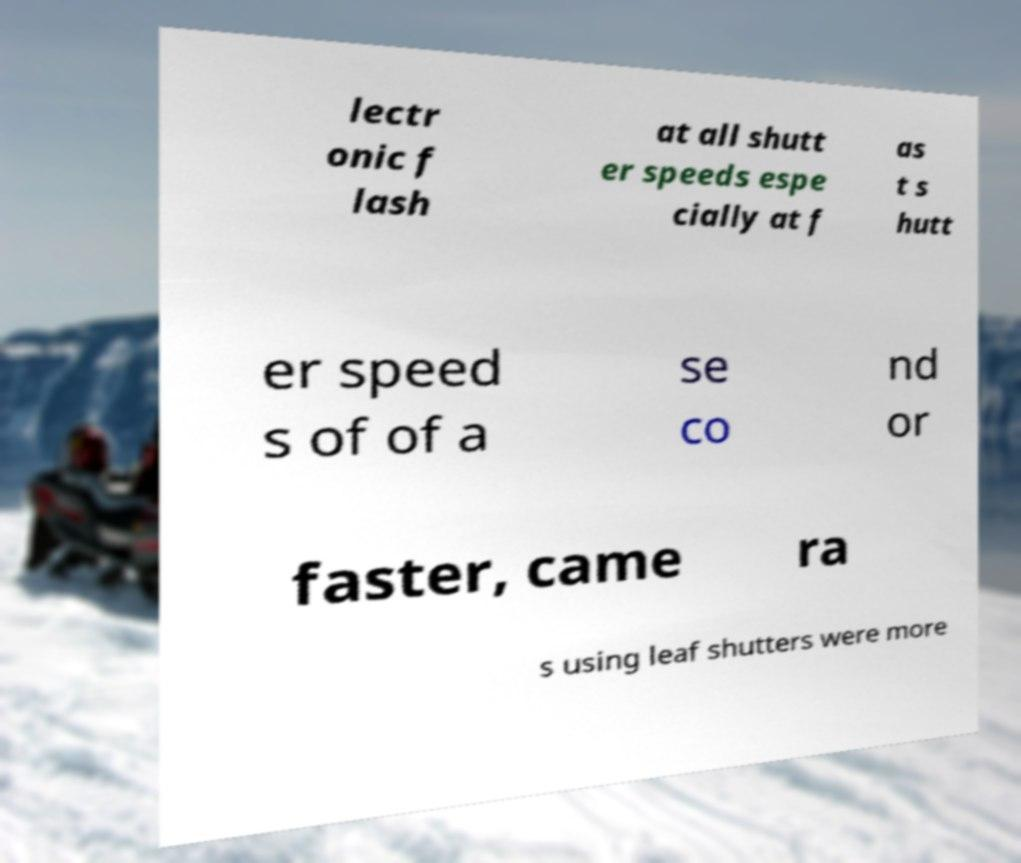Could you assist in decoding the text presented in this image and type it out clearly? lectr onic f lash at all shutt er speeds espe cially at f as t s hutt er speed s of of a se co nd or faster, came ra s using leaf shutters were more 